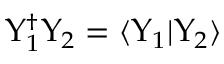<formula> <loc_0><loc_0><loc_500><loc_500>\Upsilon _ { 1 } ^ { \dagger } \Upsilon _ { 2 } = \langle \Upsilon _ { 1 } | \Upsilon _ { 2 } \rangle</formula> 